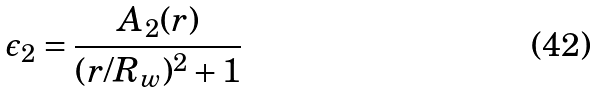Convert formula to latex. <formula><loc_0><loc_0><loc_500><loc_500>\epsilon _ { 2 } = \frac { A _ { 2 } ( r ) } { ( r / R _ { w } ) ^ { 2 } + 1 }</formula> 